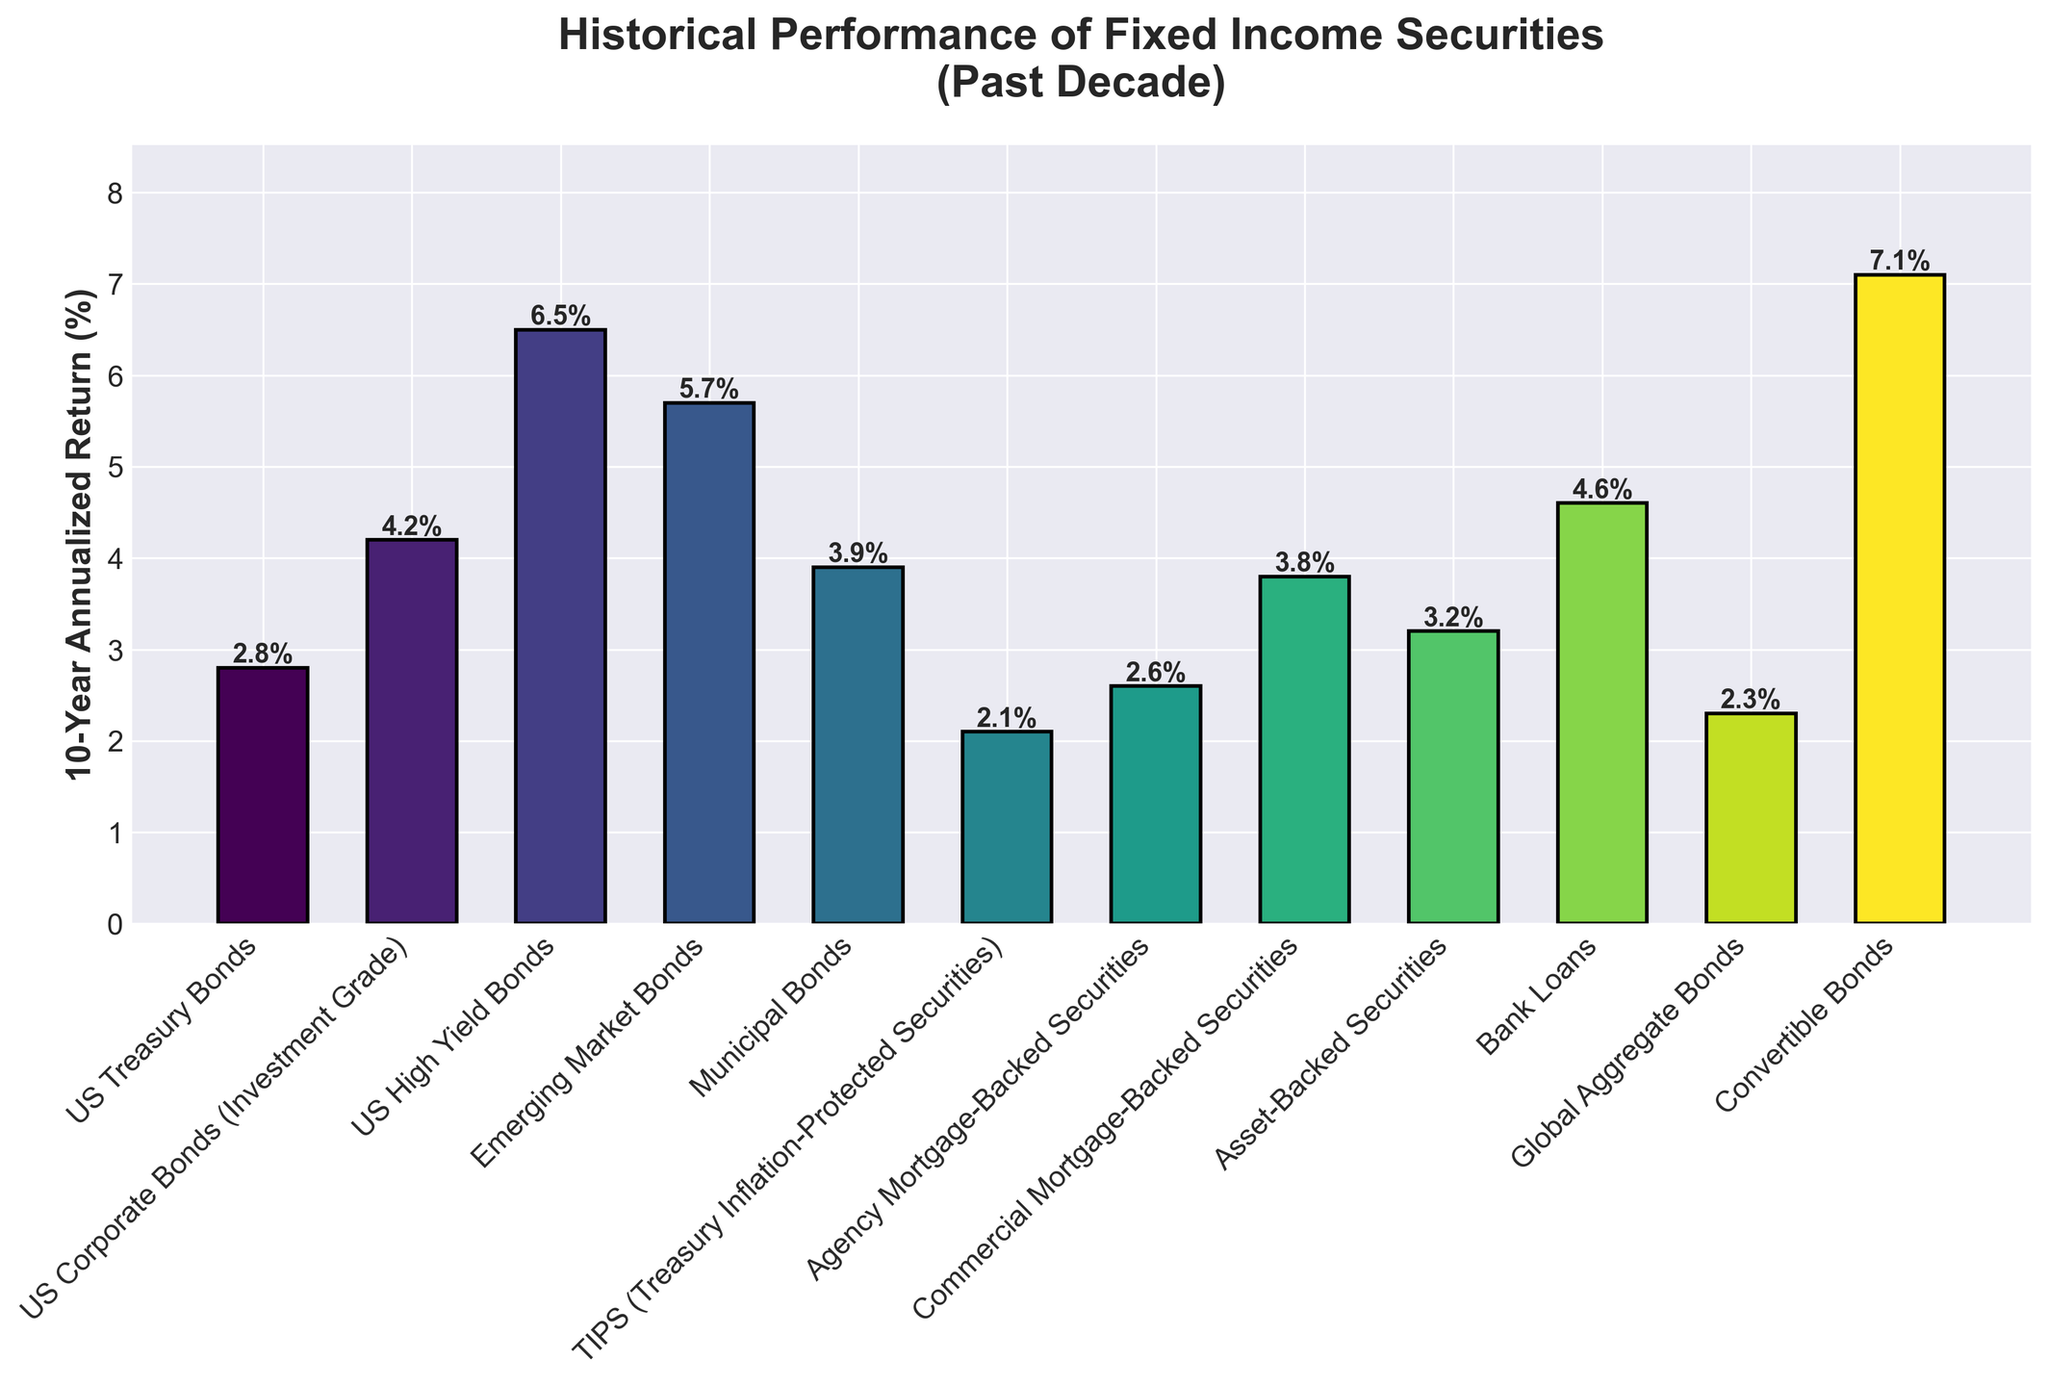Which fixed income security had the highest 10-year annualized return? Look at the heights of the bars to find the highest one, which represents the fixed income security with the largest return percentage.
Answer: Convertible Bonds Among US Treasury Bonds and Municipal Bonds, which has a higher 10-year annualized return? Compare the values shown at the top of the bars for US Treasury Bonds and Municipal Bonds.
Answer: Municipal Bonds What is the combined 10-year annualized return for TIPS and Global Aggregate Bonds? Sum the values at the top of the bars for TIPS (2.1) and Global Aggregate Bonds (2.3).
Answer: 4.4% How do US High Yield Bonds compare to Emerging Market Bonds in terms of 10-year annualized return? Compare the height of the bars and the values at the top of the bars for US High Yield Bonds (6.5) and Emerging Market Bonds (5.7).
Answer: US High Yield Bonds have a higher return What is the difference in 10-year annualized return between the fixed income security with the highest return and the one with the lowest return? Identify the highest (Convertible Bonds, 7.1) and the lowest (TIPS, 2.1) values at the top of the bars, then subtract the lowest from the highest.
Answer: 5.0% Which fixed income securities have a 10-year annualized return of more than 5% but less than 7%? Locate the bars with values greater than 5% and less than 7%. These are US High Yield Bonds (6.5) and Emerging Market Bonds (5.7).
Answer: US High Yield Bonds and Emerging Market Bonds What is the average 10-year annualized return of US Corporate Bonds (Investment Grade), Asset-Backed Securities, and Municipal Bonds? Average their returns: (4.2 + 3.2 + 3.9) / 3.
Answer: 3.8% How many fixed income securities have a 10-year annualized return below 3%? Count the bars with values below 3%: US Treasury Bonds (2.8), TIPS (2.1), Agency Mortgage-Backed Securities (2.6), and Global Aggregate Bonds (2.3).
Answer: 4 What is the total 10-year annualized return if you sum the returns of US Treasury Bonds, US Corporate Bonds (Investment Grade), and Commercial Mortgage-Backed Securities? Sum the values at the top of the bars for these securities: 2.8 + 4.2 + 3.8.
Answer: 10.8% 